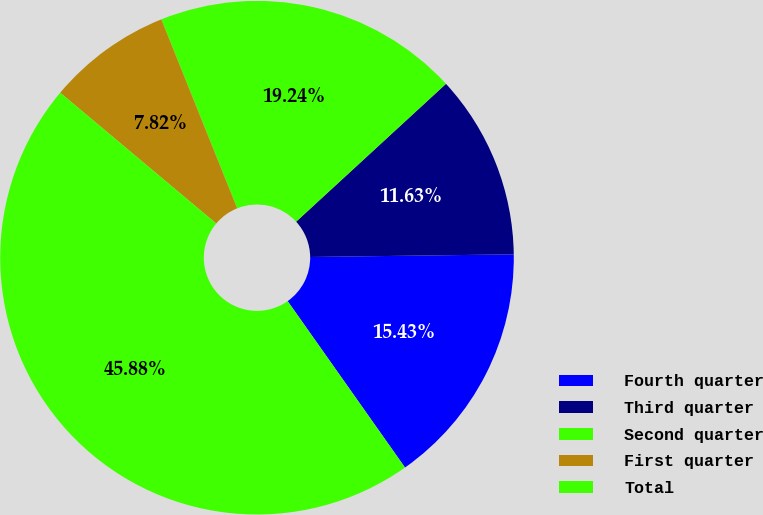Convert chart to OTSL. <chart><loc_0><loc_0><loc_500><loc_500><pie_chart><fcel>Fourth quarter<fcel>Third quarter<fcel>Second quarter<fcel>First quarter<fcel>Total<nl><fcel>15.43%<fcel>11.63%<fcel>19.24%<fcel>7.82%<fcel>45.88%<nl></chart> 